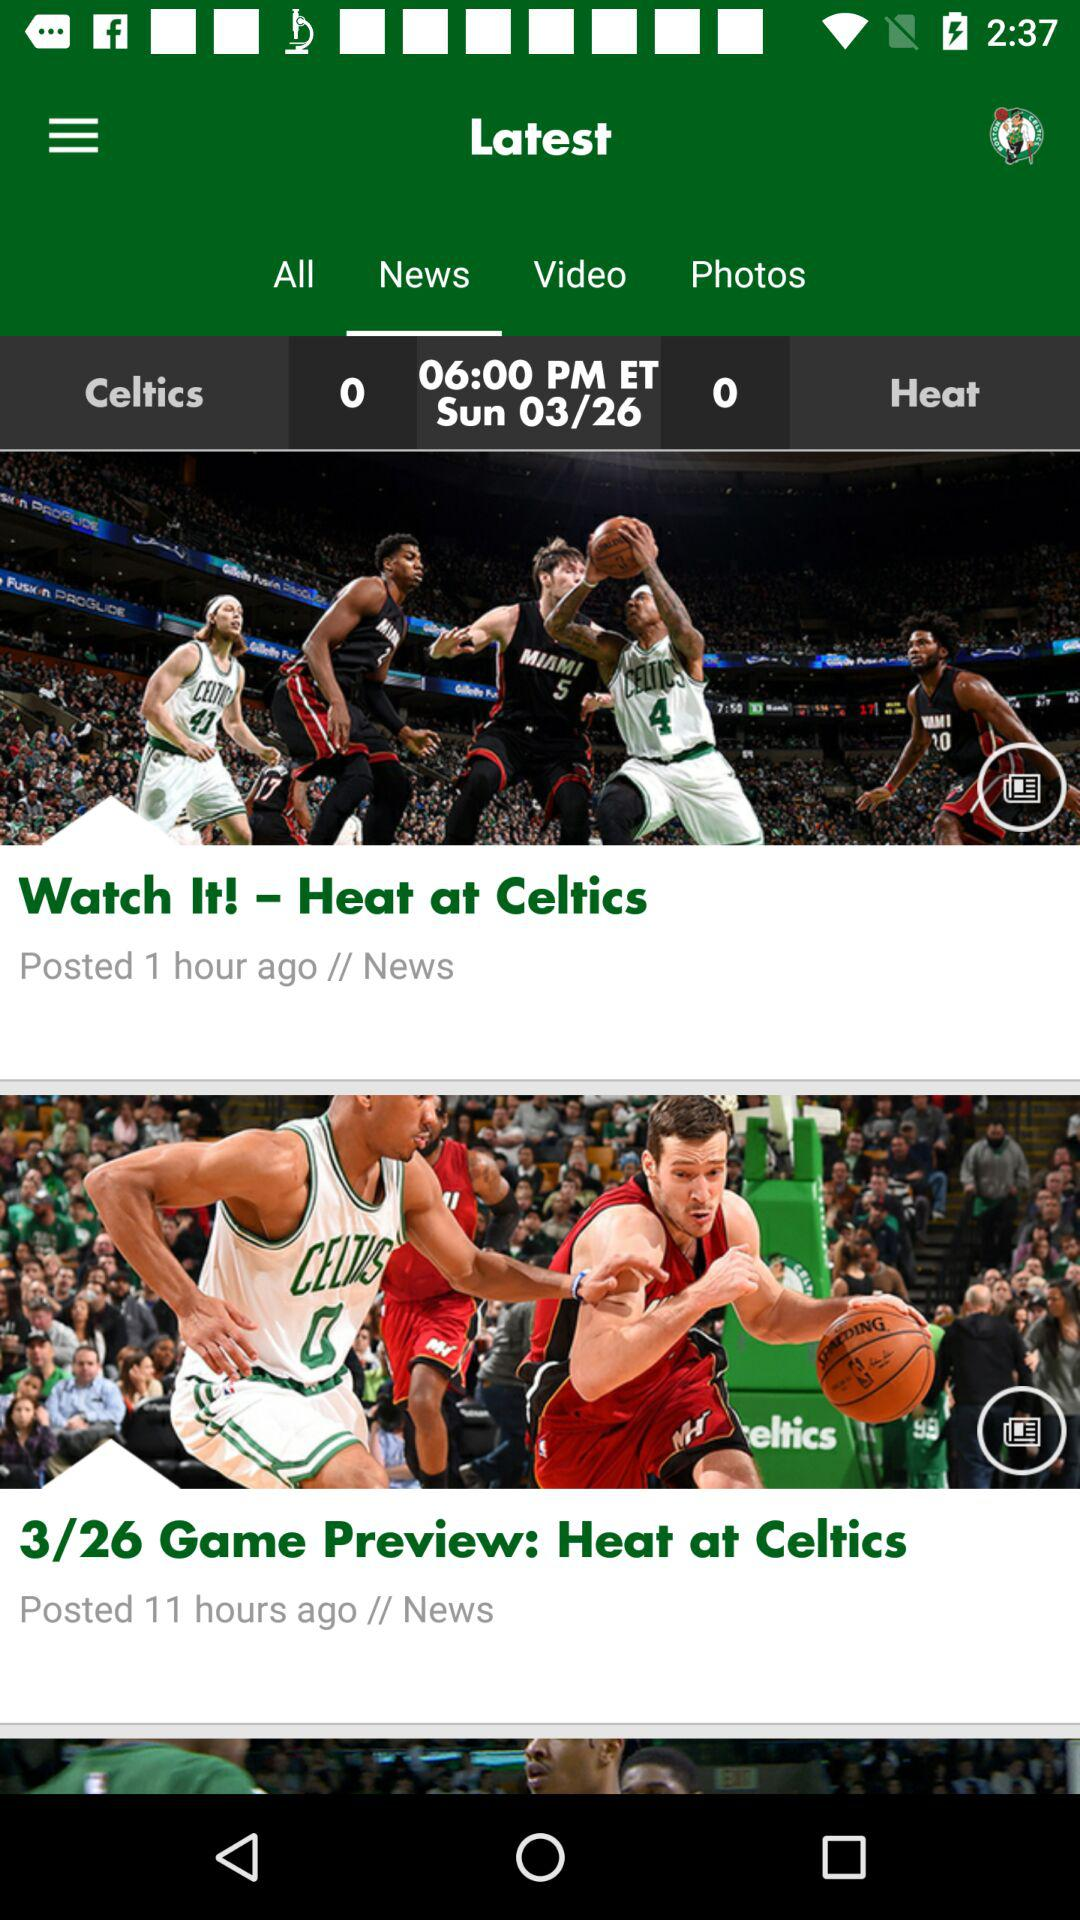What year is it?
When the provided information is insufficient, respond with <no answer>. <no answer> 